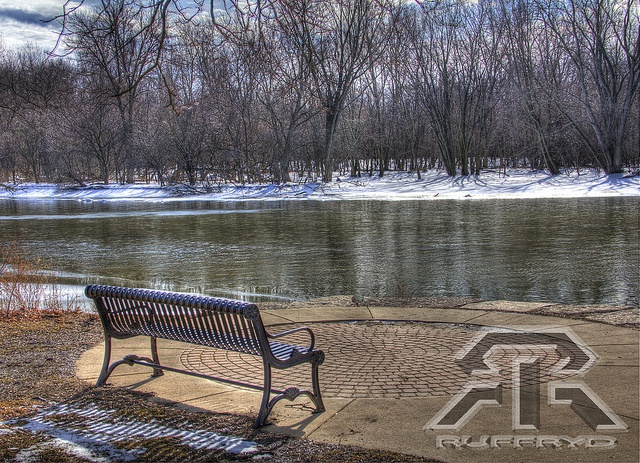Describe the objects in this image and their specific colors. I can see a bench in white, black, gray, and tan tones in this image. 